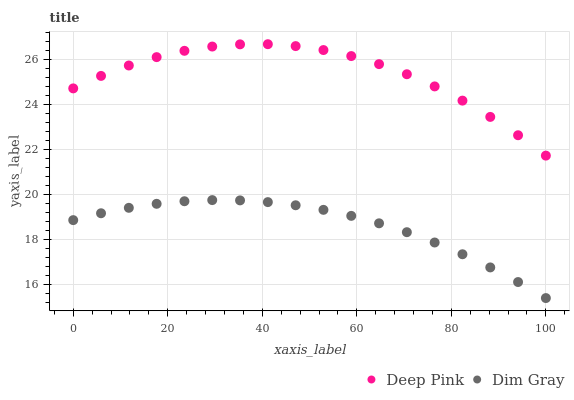Does Dim Gray have the minimum area under the curve?
Answer yes or no. Yes. Does Deep Pink have the maximum area under the curve?
Answer yes or no. Yes. Does Deep Pink have the minimum area under the curve?
Answer yes or no. No. Is Dim Gray the smoothest?
Answer yes or no. Yes. Is Deep Pink the roughest?
Answer yes or no. Yes. Is Deep Pink the smoothest?
Answer yes or no. No. Does Dim Gray have the lowest value?
Answer yes or no. Yes. Does Deep Pink have the lowest value?
Answer yes or no. No. Does Deep Pink have the highest value?
Answer yes or no. Yes. Is Dim Gray less than Deep Pink?
Answer yes or no. Yes. Is Deep Pink greater than Dim Gray?
Answer yes or no. Yes. Does Dim Gray intersect Deep Pink?
Answer yes or no. No. 